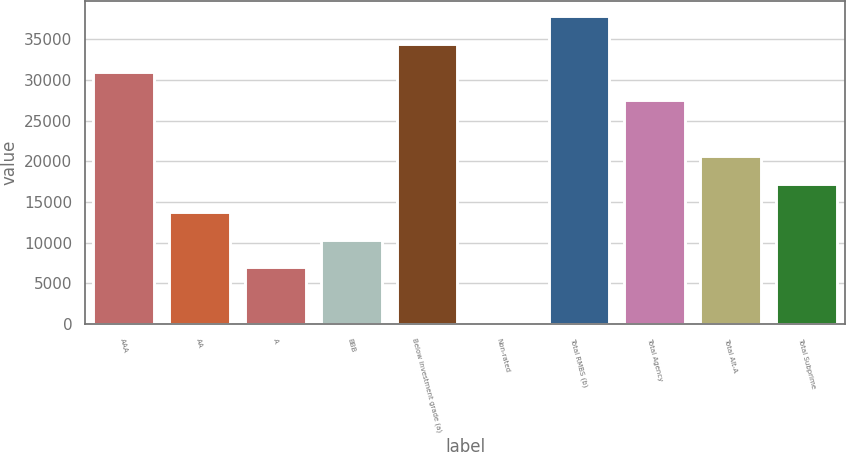Convert chart. <chart><loc_0><loc_0><loc_500><loc_500><bar_chart><fcel>AAA<fcel>AA<fcel>A<fcel>BBB<fcel>Below investment grade (a)<fcel>Non-rated<fcel>Total RMBS (b)<fcel>Total Agency<fcel>Total Alt-A<fcel>Total Subprime<nl><fcel>30963.9<fcel>13823.4<fcel>6967.2<fcel>10395.3<fcel>34392<fcel>111<fcel>37820.1<fcel>27535.8<fcel>20679.6<fcel>17251.5<nl></chart> 